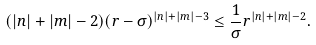Convert formula to latex. <formula><loc_0><loc_0><loc_500><loc_500>( | n | + | m | - 2 ) ( r - \sigma ) ^ { | n | + | m | - 3 } \leq \frac { 1 } { \sigma } r ^ { | n | + | m | - 2 } .</formula> 